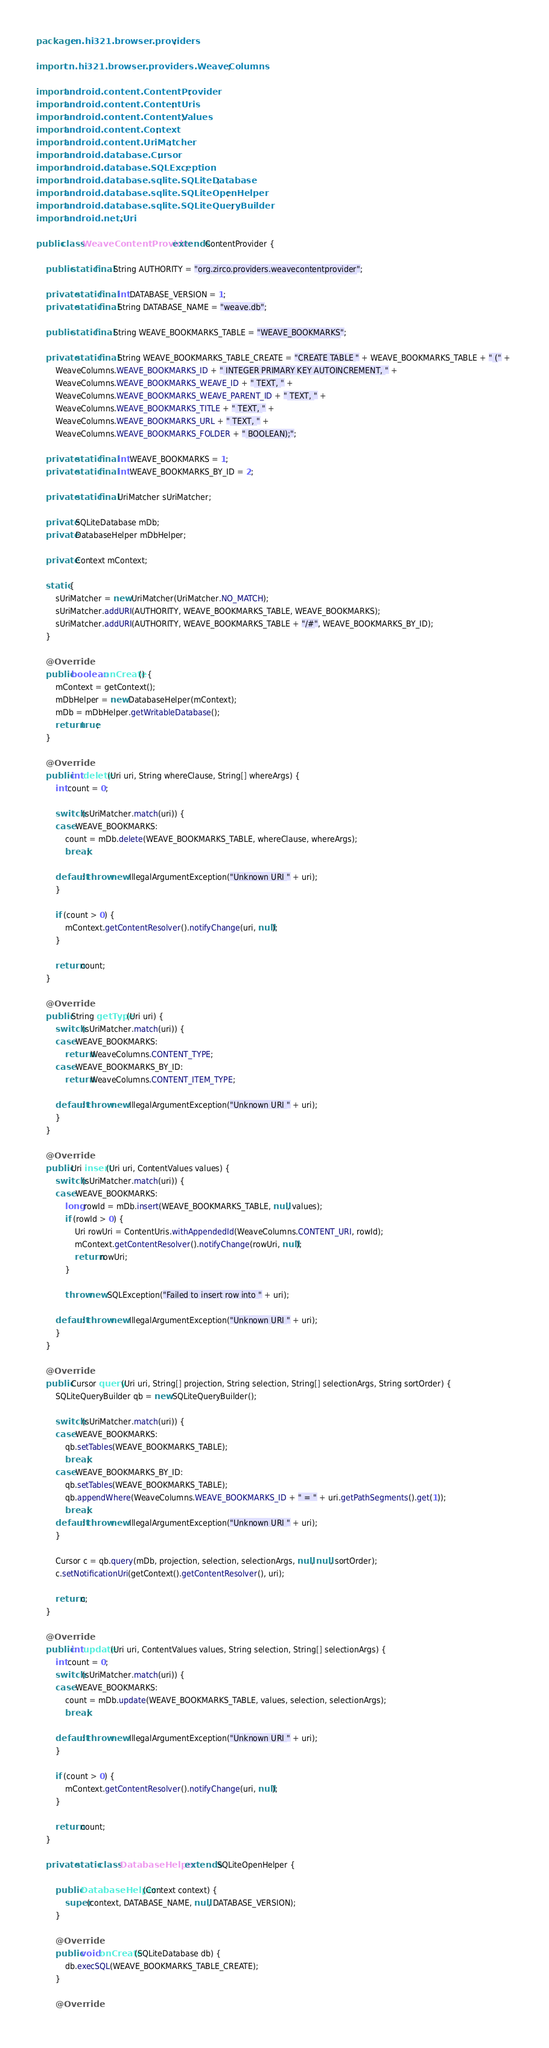<code> <loc_0><loc_0><loc_500><loc_500><_Java_>
package cn.hi321.browser.providers;

import cn.hi321.browser.providers.WeaveColumns;

import android.content.ContentProvider;
import android.content.ContentUris;
import android.content.ContentValues;
import android.content.Context;
import android.content.UriMatcher;
import android.database.Cursor;
import android.database.SQLException;
import android.database.sqlite.SQLiteDatabase;
import android.database.sqlite.SQLiteOpenHelper;
import android.database.sqlite.SQLiteQueryBuilder;
import android.net.Uri;

public class WeaveContentProvider extends ContentProvider {
	
	public static final String AUTHORITY = "org.zirco.providers.weavecontentprovider";
	
	private static final int DATABASE_VERSION = 1;
	private static final String DATABASE_NAME = "weave.db";
	
	public static final String WEAVE_BOOKMARKS_TABLE = "WEAVE_BOOKMARKS";
	
	private static final String WEAVE_BOOKMARKS_TABLE_CREATE = "CREATE TABLE " + WEAVE_BOOKMARKS_TABLE + " (" + 
		WeaveColumns.WEAVE_BOOKMARKS_ID + " INTEGER PRIMARY KEY AUTOINCREMENT, " +
		WeaveColumns.WEAVE_BOOKMARKS_WEAVE_ID + " TEXT, " +
		WeaveColumns.WEAVE_BOOKMARKS_WEAVE_PARENT_ID + " TEXT, " +
		WeaveColumns.WEAVE_BOOKMARKS_TITLE + " TEXT, " +
		WeaveColumns.WEAVE_BOOKMARKS_URL + " TEXT, " +
		WeaveColumns.WEAVE_BOOKMARKS_FOLDER + " BOOLEAN);";
	
	private static final int WEAVE_BOOKMARKS = 1;
	private static final int WEAVE_BOOKMARKS_BY_ID = 2;
	
	private static final UriMatcher sUriMatcher;
	
	private SQLiteDatabase mDb;
	private DatabaseHelper mDbHelper;
	
	private Context mContext;
	
	static {
		sUriMatcher = new UriMatcher(UriMatcher.NO_MATCH);
		sUriMatcher.addURI(AUTHORITY, WEAVE_BOOKMARKS_TABLE, WEAVE_BOOKMARKS);
		sUriMatcher.addURI(AUTHORITY, WEAVE_BOOKMARKS_TABLE + "/#", WEAVE_BOOKMARKS_BY_ID);
	}
	
	@Override
	public boolean onCreate() {
		mContext = getContext();
		mDbHelper = new DatabaseHelper(mContext);
		mDb = mDbHelper.getWritableDatabase();
		return true;
	}

	@Override
	public int delete(Uri uri, String whereClause, String[] whereArgs) {
		int count = 0;
		
		switch (sUriMatcher.match(uri)) {
		case WEAVE_BOOKMARKS:
			count = mDb.delete(WEAVE_BOOKMARKS_TABLE, whereClause, whereArgs);
			break;
			
		default: throw new IllegalArgumentException("Unknown URI " + uri);
		}		
		
		if (count > 0) {
			mContext.getContentResolver().notifyChange(uri, null);
		}
		
		return count;
	}

	@Override
	public String getType(Uri uri) {
		switch (sUriMatcher.match(uri)) {
		case WEAVE_BOOKMARKS:
			return WeaveColumns.CONTENT_TYPE;
		case WEAVE_BOOKMARKS_BY_ID:
			return WeaveColumns.CONTENT_ITEM_TYPE;

		default: throw new IllegalArgumentException("Unknown URI " + uri);
		}
	}

	@Override
	public Uri insert(Uri uri, ContentValues values) {
		switch (sUriMatcher.match(uri)) {
		case WEAVE_BOOKMARKS:
			long rowId = mDb.insert(WEAVE_BOOKMARKS_TABLE, null, values);
			if (rowId > 0) {
				Uri rowUri = ContentUris.withAppendedId(WeaveColumns.CONTENT_URI, rowId);
				mContext.getContentResolver().notifyChange(rowUri, null);
				return rowUri;
			}
			
			throw new SQLException("Failed to insert row into " + uri);
			
		default: throw new IllegalArgumentException("Unknown URI " + uri);
		}										
	}	

	@Override
	public Cursor query(Uri uri, String[] projection, String selection, String[] selectionArgs, String sortOrder) {
		SQLiteQueryBuilder qb = new SQLiteQueryBuilder();
		
		switch (sUriMatcher.match(uri)) {
		case WEAVE_BOOKMARKS:
			qb.setTables(WEAVE_BOOKMARKS_TABLE);			
			break;
		case WEAVE_BOOKMARKS_BY_ID:
			qb.setTables(WEAVE_BOOKMARKS_TABLE);
			qb.appendWhere(WeaveColumns.WEAVE_BOOKMARKS_ID + " = " + uri.getPathSegments().get(1));
			break;		
		default: throw new IllegalArgumentException("Unknown URI " + uri);
		}
		
		Cursor c = qb.query(mDb, projection, selection, selectionArgs, null, null, sortOrder);
		c.setNotificationUri(getContext().getContentResolver(), uri);
		
		return c;
	}

	@Override
	public int update(Uri uri, ContentValues values, String selection, String[] selectionArgs) {
		int count = 0;
		switch (sUriMatcher.match(uri)) {
		case WEAVE_BOOKMARKS:
			count = mDb.update(WEAVE_BOOKMARKS_TABLE, values, selection, selectionArgs);
			break;
			
		default: throw new IllegalArgumentException("Unknown URI " + uri);
		}
						
		if (count > 0) {
			mContext.getContentResolver().notifyChange(uri, null);
		}
		
		return count;
	}
	
	private static class DatabaseHelper extends SQLiteOpenHelper {

		public DatabaseHelper(Context context) {
			super(context, DATABASE_NAME, null, DATABASE_VERSION);
		}

		@Override
		public void onCreate(SQLiteDatabase db) {
			db.execSQL(WEAVE_BOOKMARKS_TABLE_CREATE);
		}

		@Override</code> 